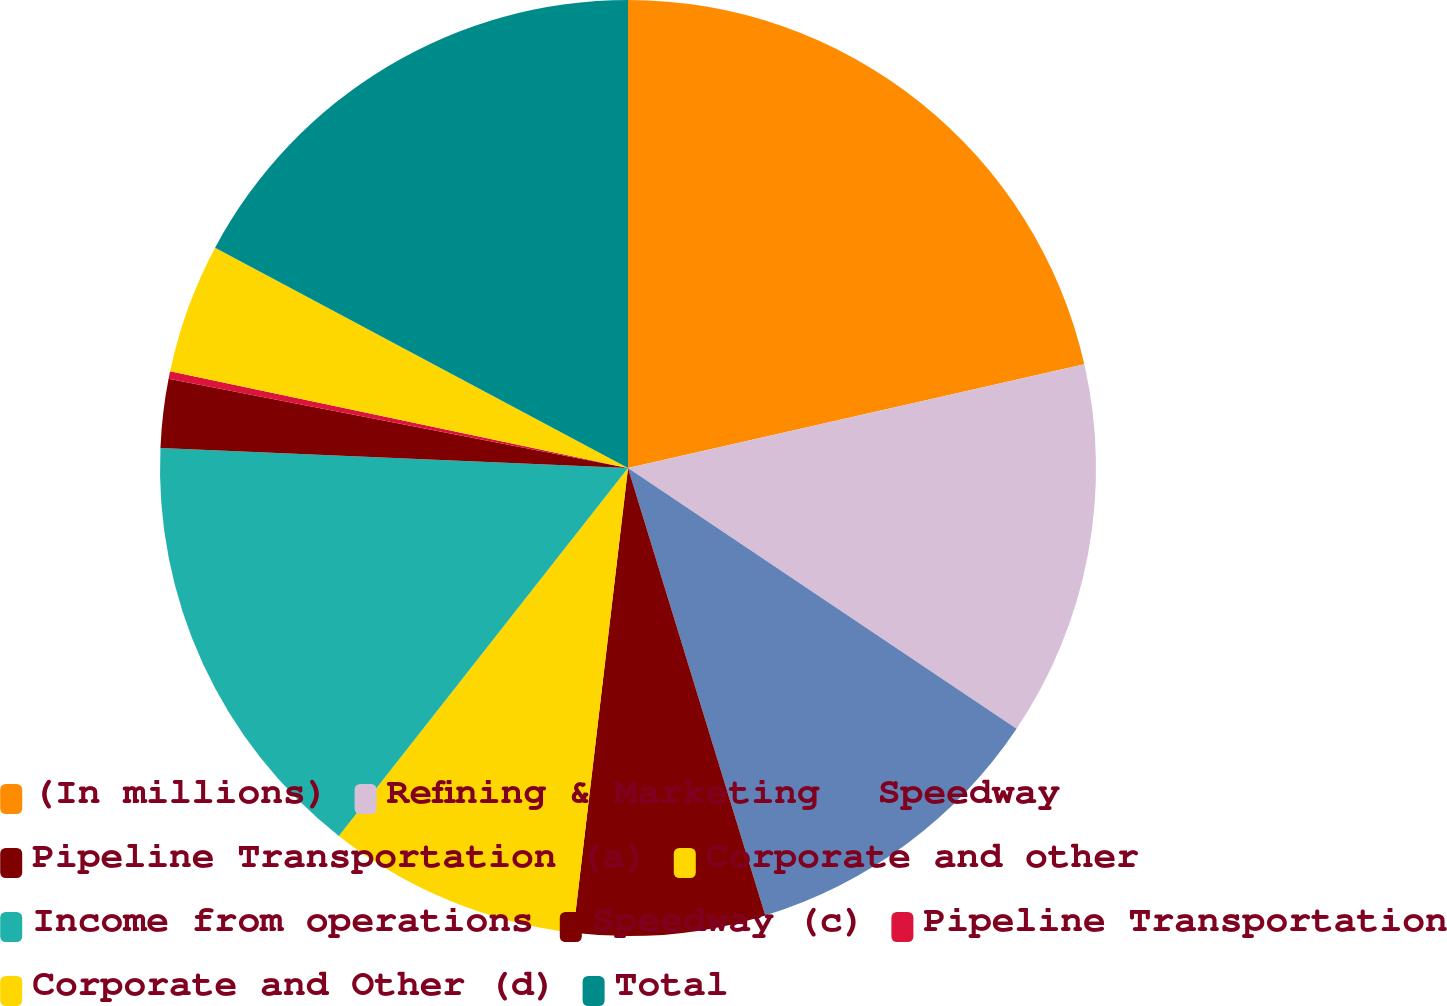Convert chart to OTSL. <chart><loc_0><loc_0><loc_500><loc_500><pie_chart><fcel>(In millions)<fcel>Refining & Marketing<fcel>Speedway<fcel>Pipeline Transportation (a)<fcel>Corporate and other<fcel>Income from operations<fcel>Speedway (c)<fcel>Pipeline Transportation<fcel>Corporate and Other (d)<fcel>Total<nl><fcel>21.44%<fcel>12.97%<fcel>10.85%<fcel>6.61%<fcel>8.73%<fcel>15.08%<fcel>2.37%<fcel>0.26%<fcel>4.49%<fcel>17.2%<nl></chart> 